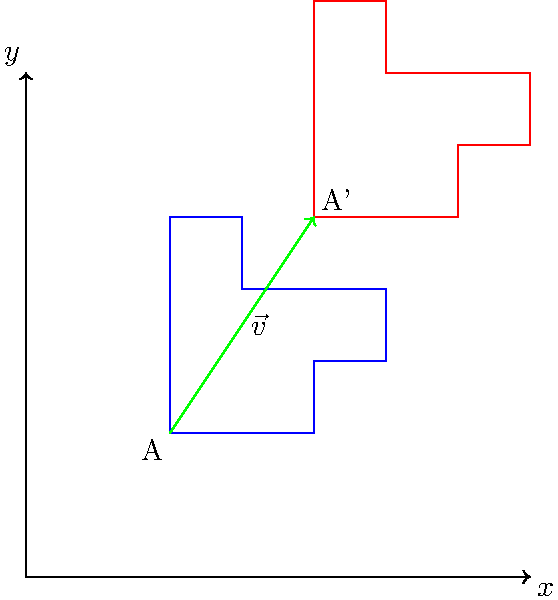In a virtual reality simulation designed to teach transformational geometry, a complex shape A is translated across a coordinate plane by vector $\vec{v} = (2, 3)$. The vertex at $(1, 1)$ moves to $(3, 4)$ after the translation. What are the coordinates of the vertex that was originally at $(4, 3)$ after the translation? To solve this problem, we'll follow these steps:

1) First, we need to understand what translation means. Translation moves every point of a shape by the same distance in the same direction.

2) We're given that the translation vector $\vec{v} = (2, 3)$. This means that every point of the shape is moved 2 units in the x-direction and 3 units in the y-direction.

3) We're asked about the point that was originally at $(4, 3)$. Let's call this point P.

4) To find the new coordinates of P, we add the components of the translation vector to the original coordinates:

   New x-coordinate = Original x-coordinate + x-component of $\vec{v}$
   $x' = 4 + 2 = 6$

   New y-coordinate = Original y-coordinate + y-component of $\vec{v}$
   $y' = 3 + 3 = 6$

5) Therefore, after the translation, the point P moves from $(4, 3)$ to $(6, 6)$.

This problem demonstrates how translations affect complex shapes in a coordinate plane, which is a fundamental concept in transformational geometry and can be effectively visualized and manipulated in virtual reality environments for enhanced learning outcomes.
Answer: $(6, 6)$ 